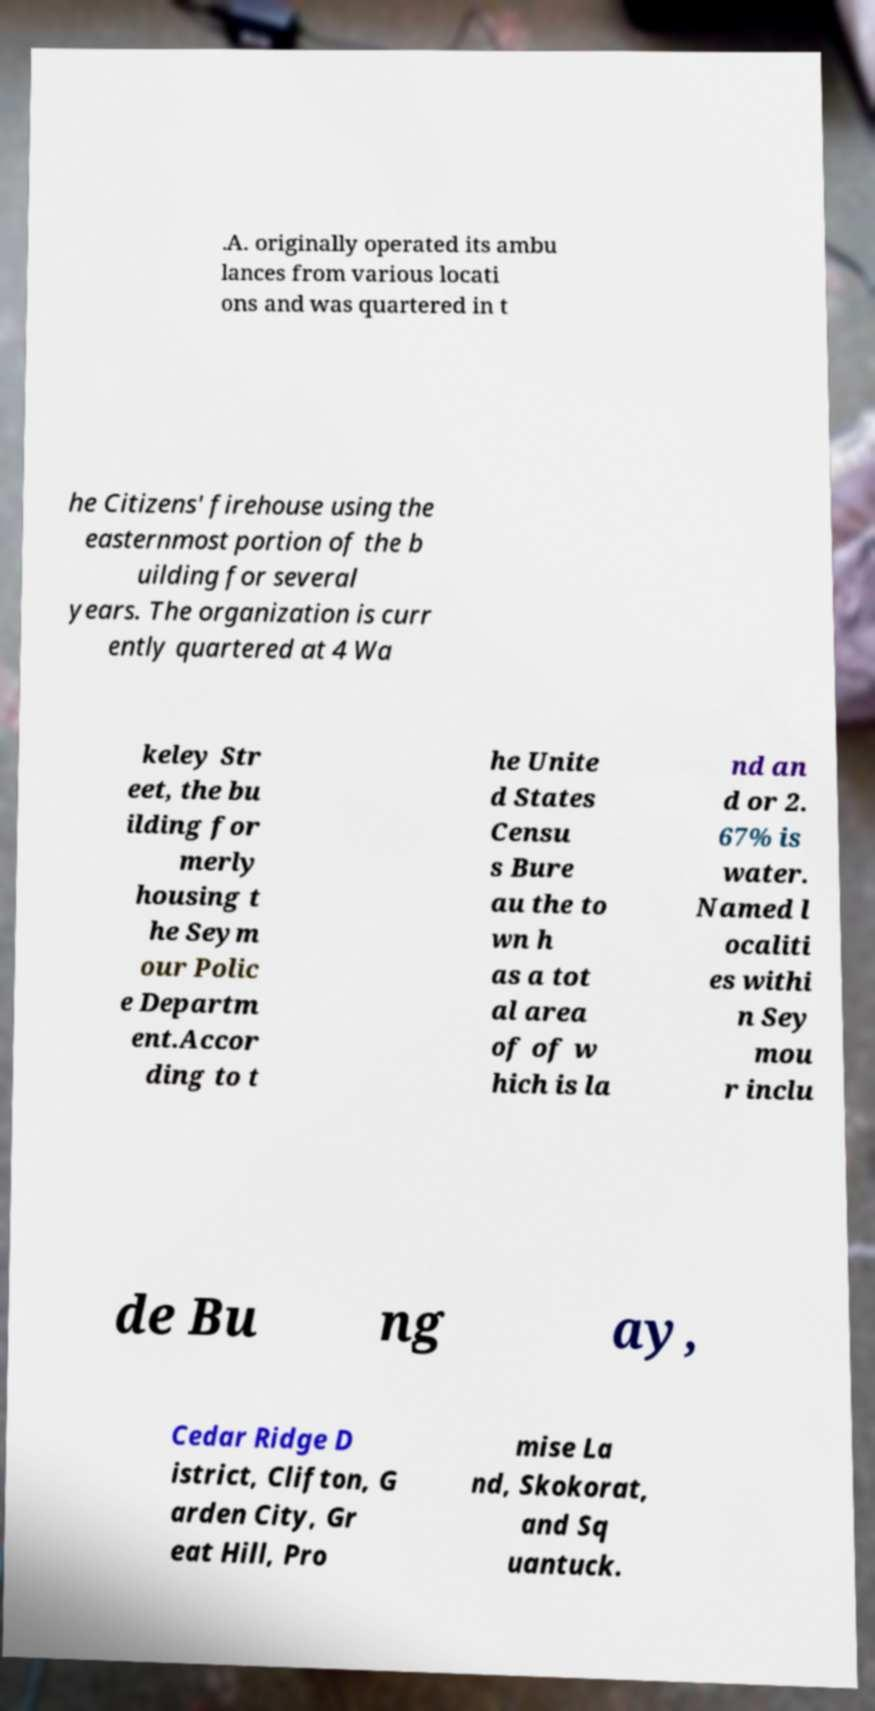For documentation purposes, I need the text within this image transcribed. Could you provide that? .A. originally operated its ambu lances from various locati ons and was quartered in t he Citizens' firehouse using the easternmost portion of the b uilding for several years. The organization is curr ently quartered at 4 Wa keley Str eet, the bu ilding for merly housing t he Seym our Polic e Departm ent.Accor ding to t he Unite d States Censu s Bure au the to wn h as a tot al area of of w hich is la nd an d or 2. 67% is water. Named l ocaliti es withi n Sey mou r inclu de Bu ng ay, Cedar Ridge D istrict, Clifton, G arden City, Gr eat Hill, Pro mise La nd, Skokorat, and Sq uantuck. 